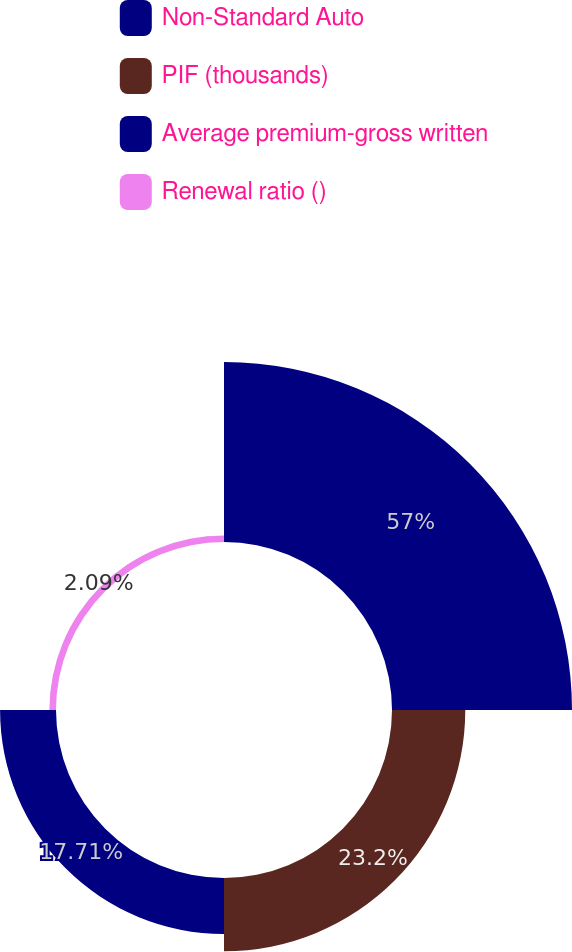<chart> <loc_0><loc_0><loc_500><loc_500><pie_chart><fcel>Non-Standard Auto<fcel>PIF (thousands)<fcel>Average premium-gross written<fcel>Renewal ratio ()<nl><fcel>56.99%<fcel>23.2%<fcel>17.71%<fcel>2.09%<nl></chart> 